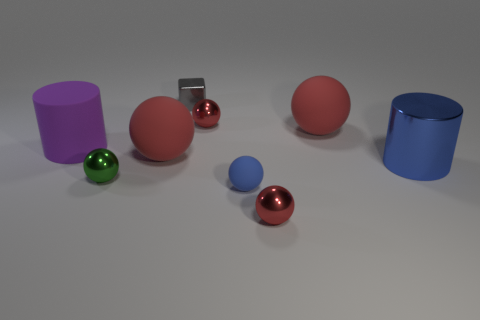Subtract all blue spheres. How many spheres are left? 5 Subtract all red balls. How many balls are left? 2 Add 7 metal cylinders. How many metal cylinders are left? 8 Add 8 large red things. How many large red things exist? 10 Subtract 0 cyan blocks. How many objects are left? 9 Subtract all spheres. How many objects are left? 3 Subtract 1 cylinders. How many cylinders are left? 1 Subtract all red blocks. Subtract all cyan balls. How many blocks are left? 1 Subtract all green blocks. How many red spheres are left? 4 Subtract all purple shiny balls. Subtract all gray blocks. How many objects are left? 8 